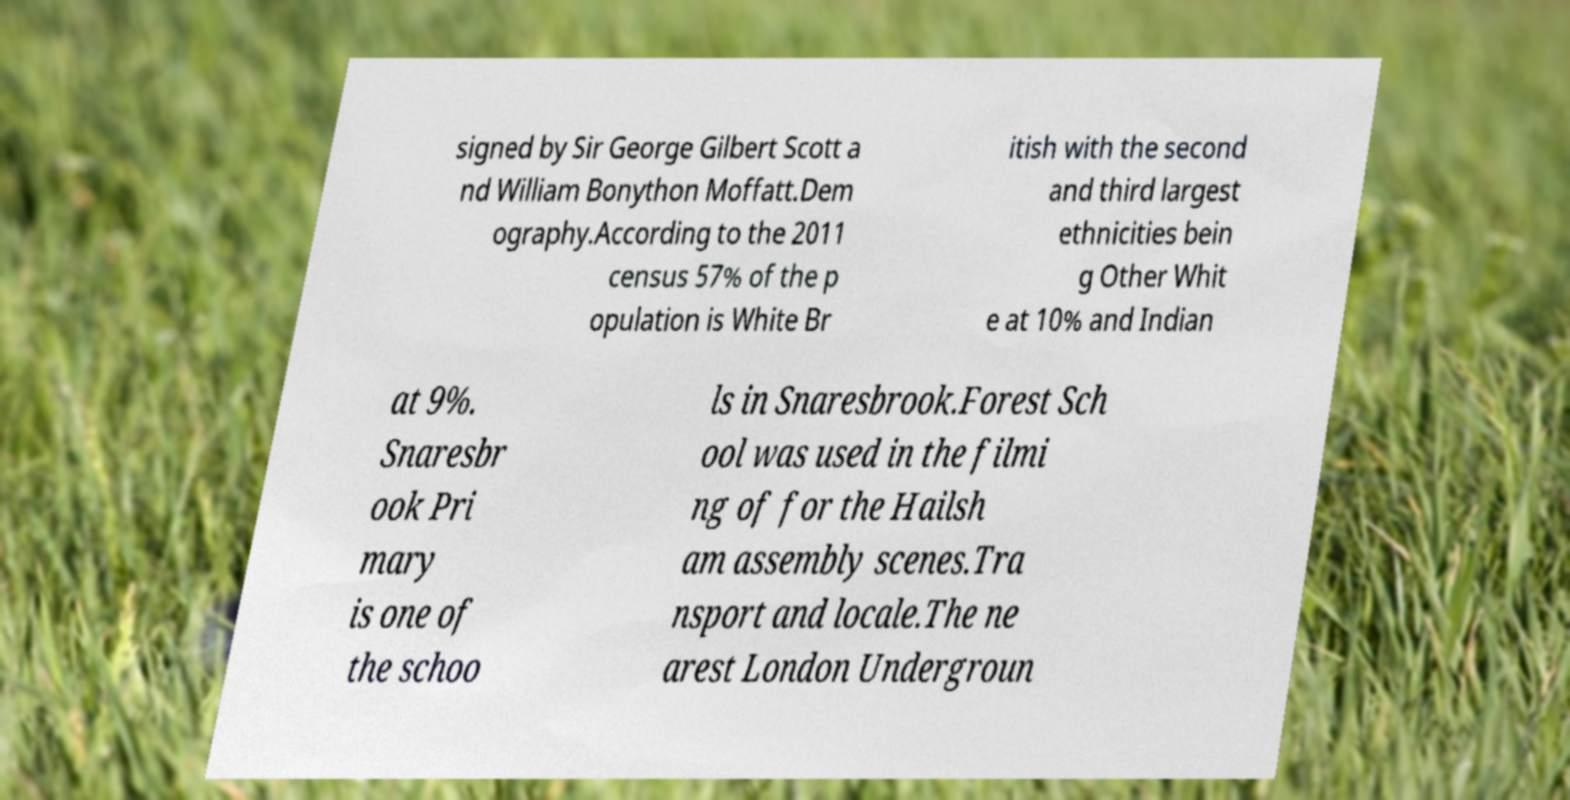Please read and relay the text visible in this image. What does it say? signed by Sir George Gilbert Scott a nd William Bonython Moffatt.Dem ography.According to the 2011 census 57% of the p opulation is White Br itish with the second and third largest ethnicities bein g Other Whit e at 10% and Indian at 9%. Snaresbr ook Pri mary is one of the schoo ls in Snaresbrook.Forest Sch ool was used in the filmi ng of for the Hailsh am assembly scenes.Tra nsport and locale.The ne arest London Undergroun 